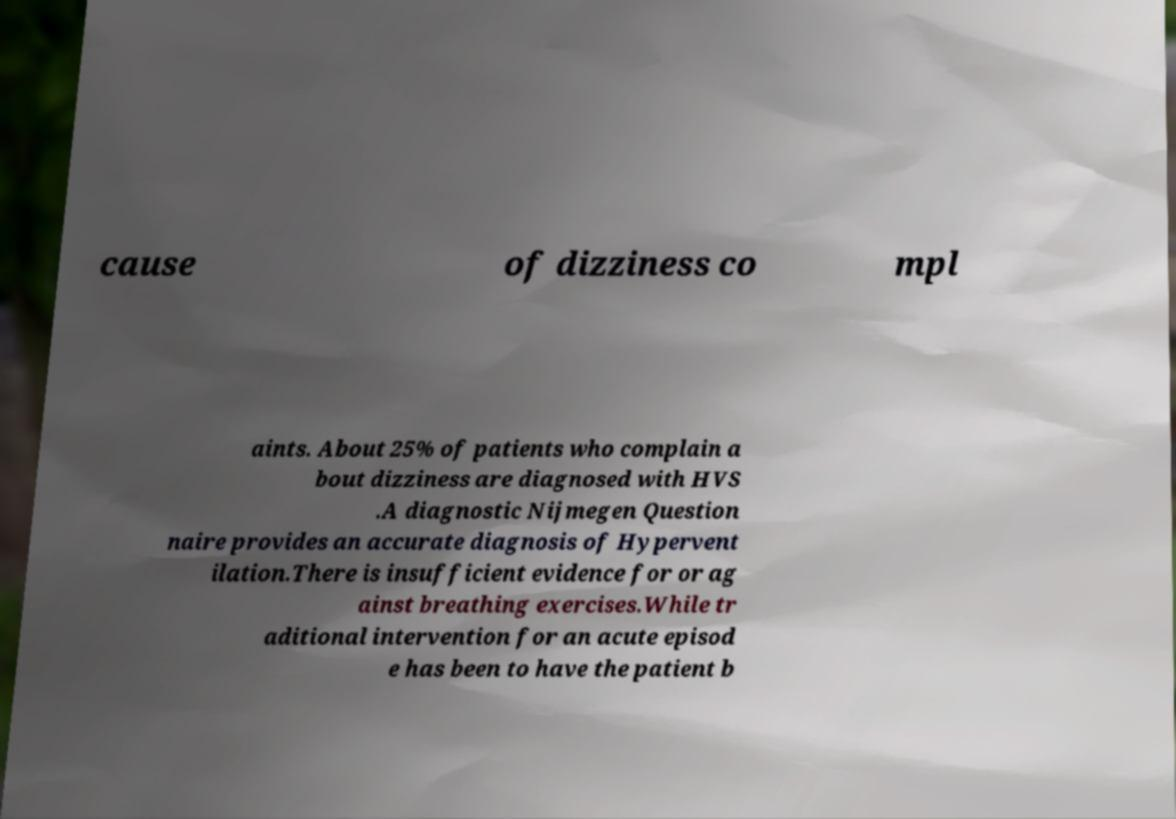Could you assist in decoding the text presented in this image and type it out clearly? cause of dizziness co mpl aints. About 25% of patients who complain a bout dizziness are diagnosed with HVS .A diagnostic Nijmegen Question naire provides an accurate diagnosis of Hypervent ilation.There is insufficient evidence for or ag ainst breathing exercises.While tr aditional intervention for an acute episod e has been to have the patient b 